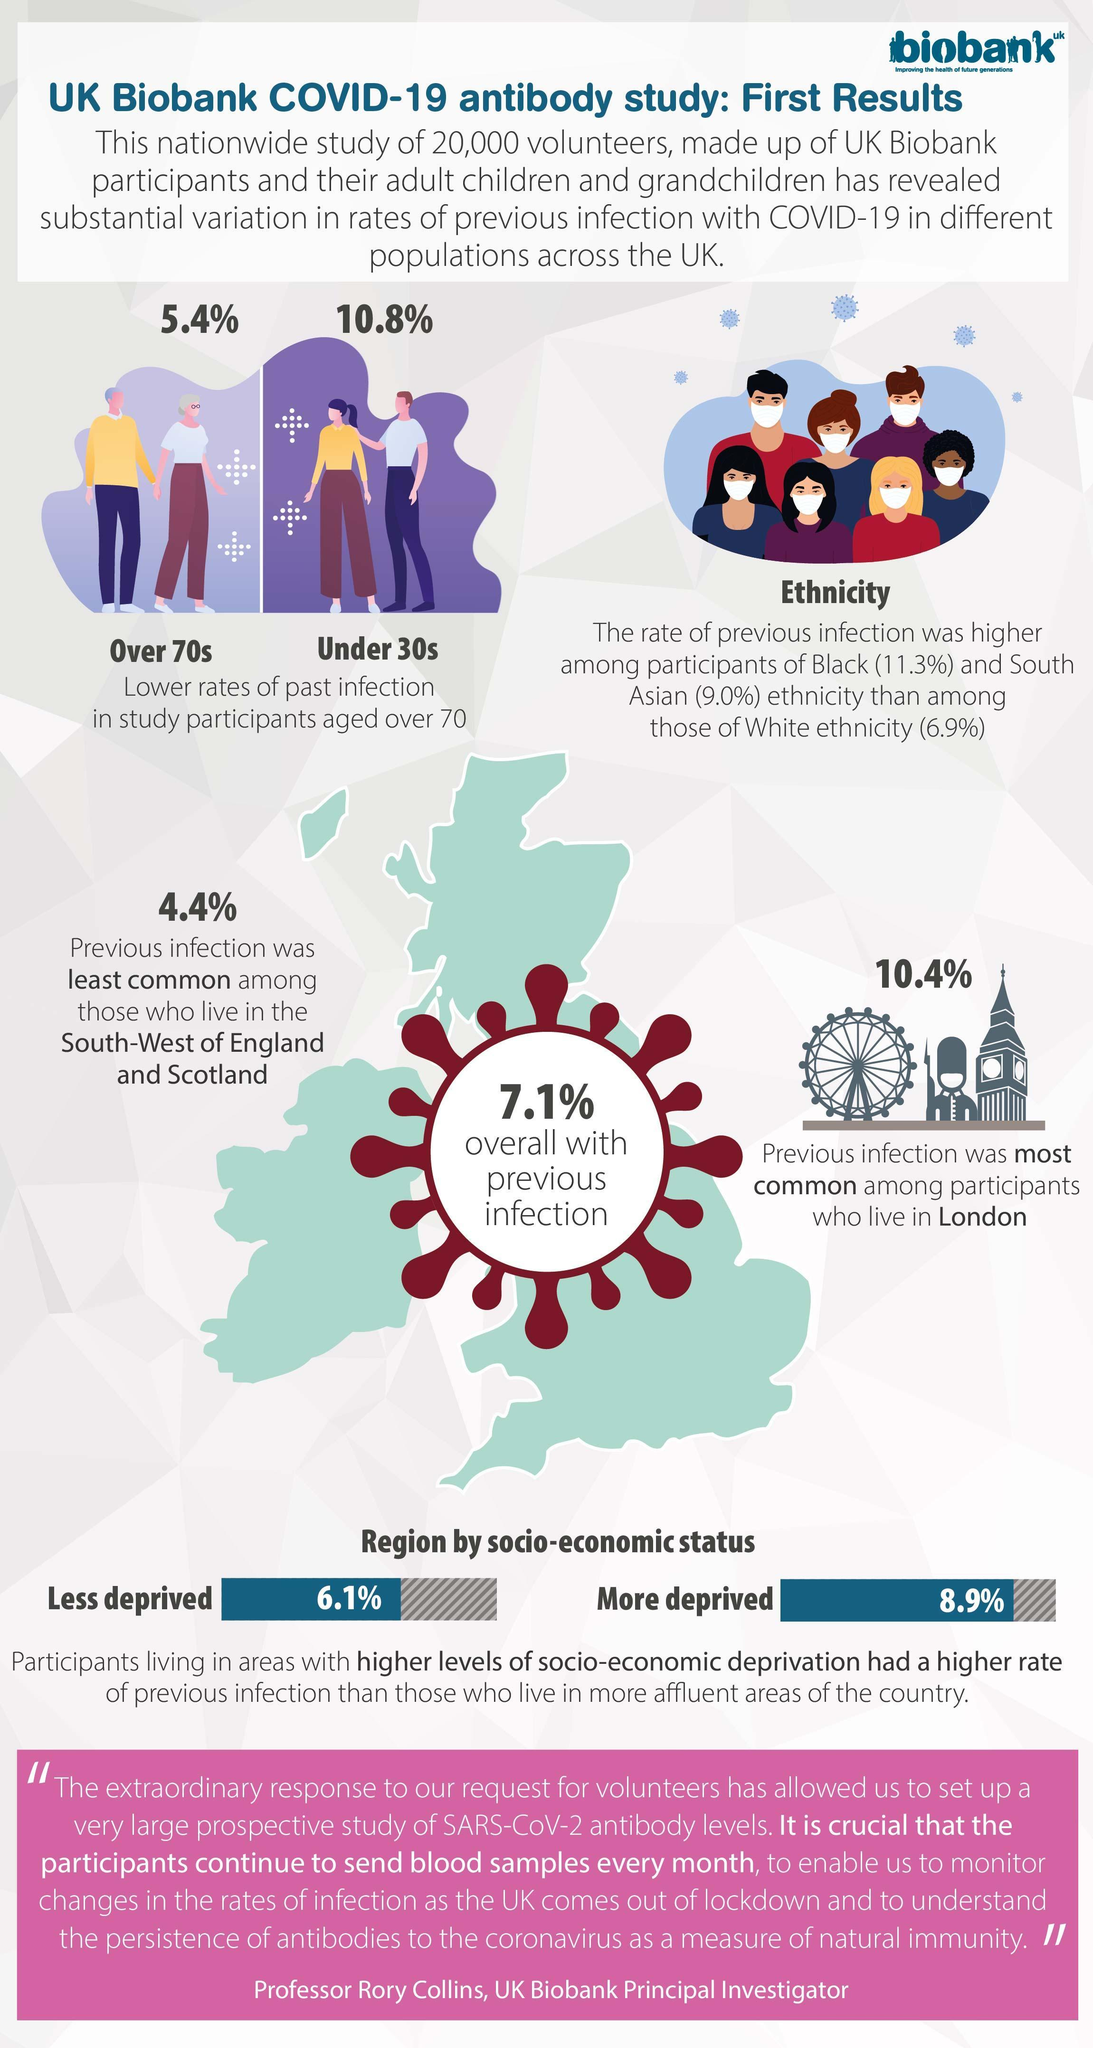What is the rate of overall previous infection?
Answer the question with a short phrase. 7.1% What is the rate of past infections in participants over the age of 70? 5.4% Where was previous infection most common? London What is the rate of past infections in participants under 30s? 10.8% What was the rate of previous infection, for those who live in more affluent areas ? 6.1% Where was previous infection least common? South-West of England and Scotland By how much, was the 'rate of previous infection' in Black participants higher than that of South Asians? 2.3% What was the rate of previous infection, for those living in, South-West of England and Scotland? 4.4% By how much, was the rate of previous infection higher in 'more deprived' participants than in 'less deprived'? 2.8% Which two ethnic groups had a higher rate of past infection when compared to the Whites? Black, South Asian 